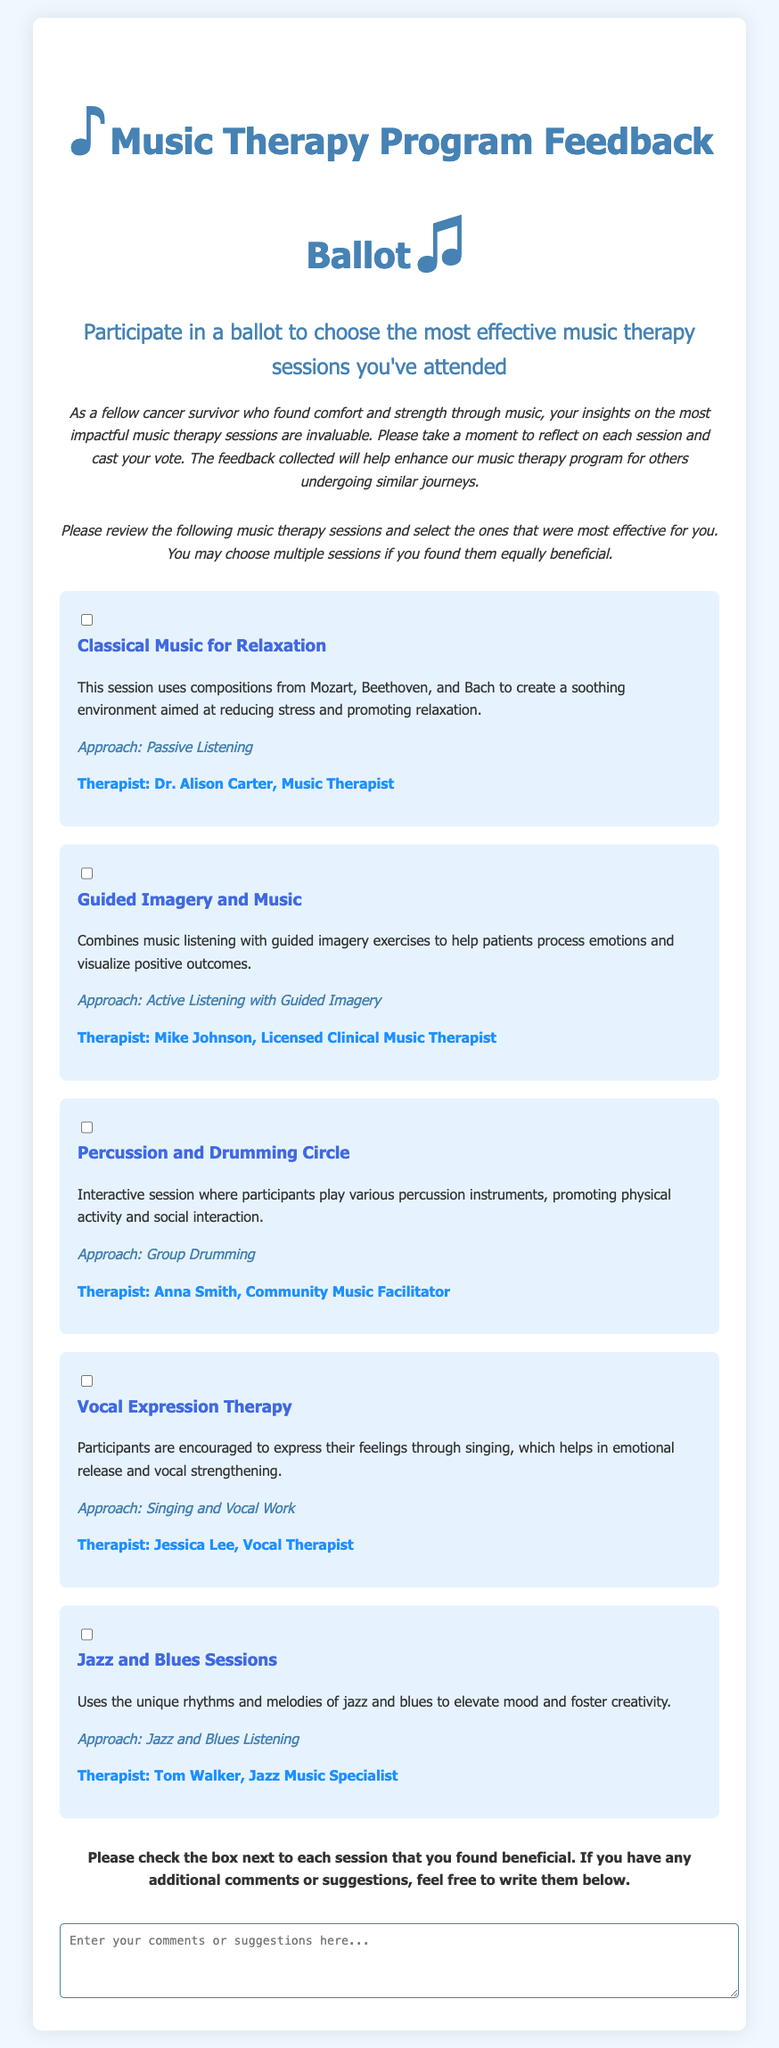What is the title of the feedback ballot? The title of the ballot is presented in the header of the document, which is "Music Therapy Program Feedback Ballot."
Answer: Music Therapy Program Feedback Ballot Who is the therapist for the Classical Music for Relaxation session? The therapist's name is mentioned in the description of the Classical Music session, which states "Therapist: Dr. Alison Carter, Music Therapist."
Answer: Dr. Alison Carter What approach is used in the Guided Imagery and Music session? The approach for the Guided Imagery and Music session is provided in the session details, where it states "Approach: Active Listening with Guided Imagery."
Answer: Active Listening with Guided Imagery How many types of therapy sessions are listed in the ballot? The document enumerates five distinct therapy sessions that participants can choose from, as organized in the sessions section of the ballot.
Answer: Five Which session encourages participants to express feelings through singing? The session details include a specifically titled session, which is "Vocal Expression Therapy," that promotes expressing feelings through music.
Answer: Vocal Expression Therapy What therapeutic approach is used in the Percussion and Drumming Circle? The document identifies the approach listed under the Percussion and Drumming Circle session, which is "Approach: Group Drumming."
Answer: Group Drumming What is the main purpose of the ballot feedback? The purpose of collecting feedback through this ballot is directly stated at the beginning, focusing on improving the music therapy program for others.
Answer: Enhancing the music therapy program Who is the therapist for the Jazz and Blues Sessions? The document provides the name of the therapist for this session, which is "Tom Walker, Jazz Music Specialist."
Answer: Tom Walker What is the instruction given for additional comments? The instruction for comments is indicated in the section before the feedback area, stating "If you have any additional comments or suggestions, feel free to write them below."
Answer: Additional comments or suggestions 